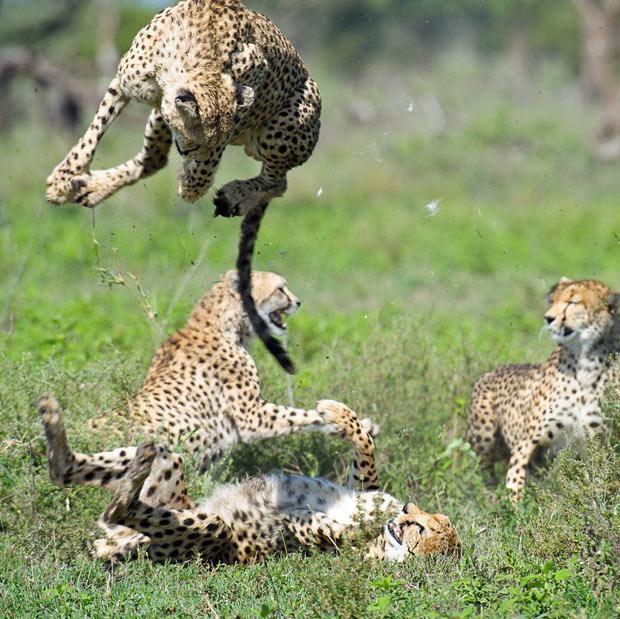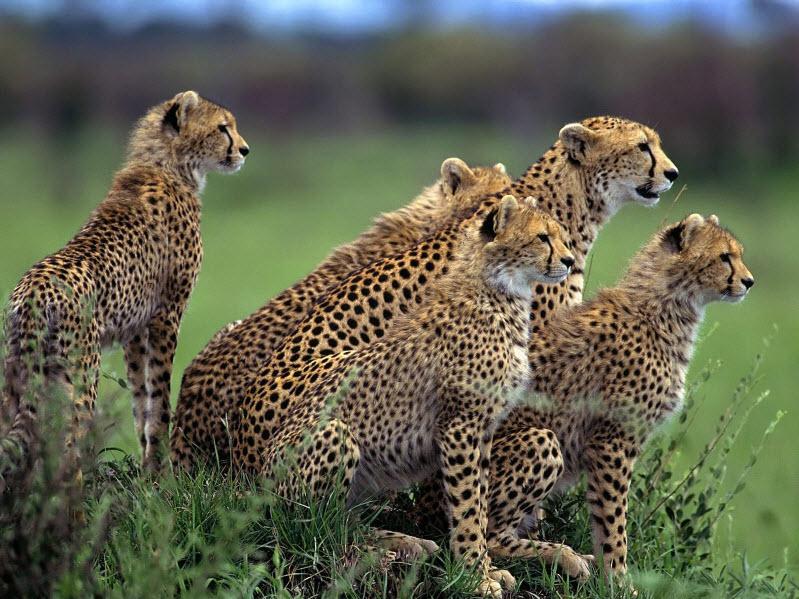The first image is the image on the left, the second image is the image on the right. Considering the images on both sides, is "An image depicts just one cheetah, which is in a leaping pose." valid? Answer yes or no. No. 